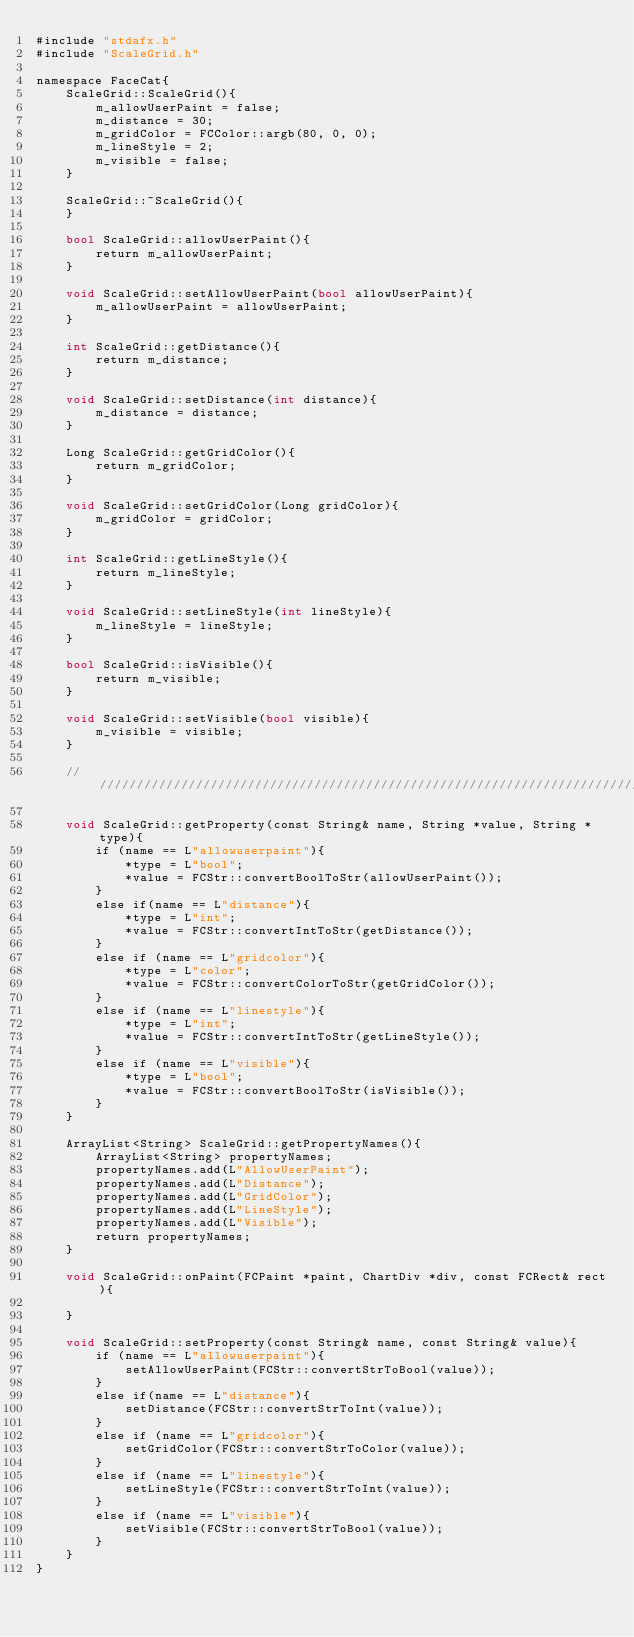Convert code to text. <code><loc_0><loc_0><loc_500><loc_500><_ObjectiveC_>#include "stdafx.h"
#include "ScaleGrid.h"

namespace FaceCat{
    ScaleGrid::ScaleGrid(){
        m_allowUserPaint = false;
        m_distance = 30;
        m_gridColor = FCColor::argb(80, 0, 0);
        m_lineStyle = 2;
        m_visible = false;
    }
    
    ScaleGrid::~ScaleGrid(){
    }
    
    bool ScaleGrid::allowUserPaint(){
        return m_allowUserPaint;
    }
    
    void ScaleGrid::setAllowUserPaint(bool allowUserPaint){
        m_allowUserPaint = allowUserPaint;
    }
    
    int ScaleGrid::getDistance(){
        return m_distance;
    }
    
    void ScaleGrid::setDistance(int distance){
        m_distance = distance;
    }
    
    Long ScaleGrid::getGridColor(){
        return m_gridColor;
    }
    
    void ScaleGrid::setGridColor(Long gridColor){
        m_gridColor = gridColor;
    }
    
    int ScaleGrid::getLineStyle(){
        return m_lineStyle;
    }
    
    void ScaleGrid::setLineStyle(int lineStyle){
        m_lineStyle = lineStyle;
    }
    
    bool ScaleGrid::isVisible(){
        return m_visible;
    }
    
    void ScaleGrid::setVisible(bool visible){
        m_visible = visible;
    }
    
    ///////////////////////////////////////////////////////////////////////////////////////////////////////////
    
    void ScaleGrid::getProperty(const String& name, String *value, String *type){
        if (name == L"allowuserpaint"){
            *type = L"bool";
            *value = FCStr::convertBoolToStr(allowUserPaint());
        }
        else if(name == L"distance"){
            *type = L"int";
            *value = FCStr::convertIntToStr(getDistance());
        }
        else if (name == L"gridcolor"){
            *type = L"color";
            *value = FCStr::convertColorToStr(getGridColor());
        }
        else if (name == L"linestyle"){
            *type = L"int";
            *value = FCStr::convertIntToStr(getLineStyle());
        }
        else if (name == L"visible"){
            *type = L"bool";
            *value = FCStr::convertBoolToStr(isVisible());
        }
    }
    
    ArrayList<String> ScaleGrid::getPropertyNames(){
        ArrayList<String> propertyNames;
        propertyNames.add(L"AllowUserPaint");
        propertyNames.add(L"Distance");
        propertyNames.add(L"GridColor");
        propertyNames.add(L"LineStyle");
        propertyNames.add(L"Visible");
        return propertyNames;
    }
    
    void ScaleGrid::onPaint(FCPaint *paint, ChartDiv *div, const FCRect& rect){
        
    }
    
    void ScaleGrid::setProperty(const String& name, const String& value){
        if (name == L"allowuserpaint"){
            setAllowUserPaint(FCStr::convertStrToBool(value));
        }
        else if(name == L"distance"){
            setDistance(FCStr::convertStrToInt(value));
        }
        else if (name == L"gridcolor"){
            setGridColor(FCStr::convertStrToColor(value));
        }
        else if (name == L"linestyle"){
            setLineStyle(FCStr::convertStrToInt(value));
        }
        else if (name == L"visible"){
            setVisible(FCStr::convertStrToBool(value));
        }
    }
}
</code> 